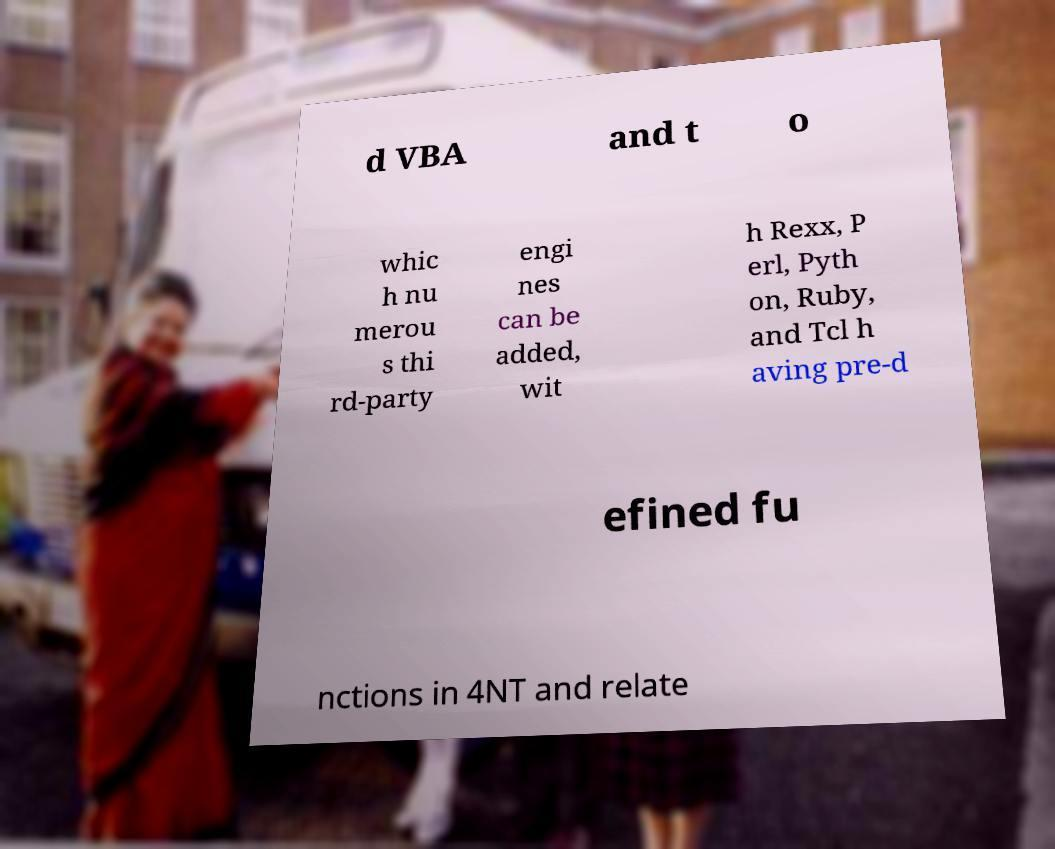What messages or text are displayed in this image? I need them in a readable, typed format. d VBA and t o whic h nu merou s thi rd-party engi nes can be added, wit h Rexx, P erl, Pyth on, Ruby, and Tcl h aving pre-d efined fu nctions in 4NT and relate 